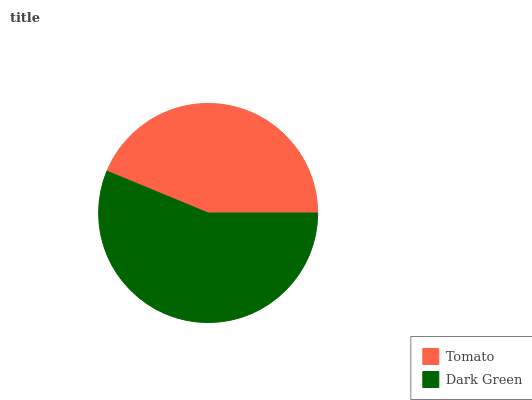Is Tomato the minimum?
Answer yes or no. Yes. Is Dark Green the maximum?
Answer yes or no. Yes. Is Dark Green the minimum?
Answer yes or no. No. Is Dark Green greater than Tomato?
Answer yes or no. Yes. Is Tomato less than Dark Green?
Answer yes or no. Yes. Is Tomato greater than Dark Green?
Answer yes or no. No. Is Dark Green less than Tomato?
Answer yes or no. No. Is Dark Green the high median?
Answer yes or no. Yes. Is Tomato the low median?
Answer yes or no. Yes. Is Tomato the high median?
Answer yes or no. No. Is Dark Green the low median?
Answer yes or no. No. 